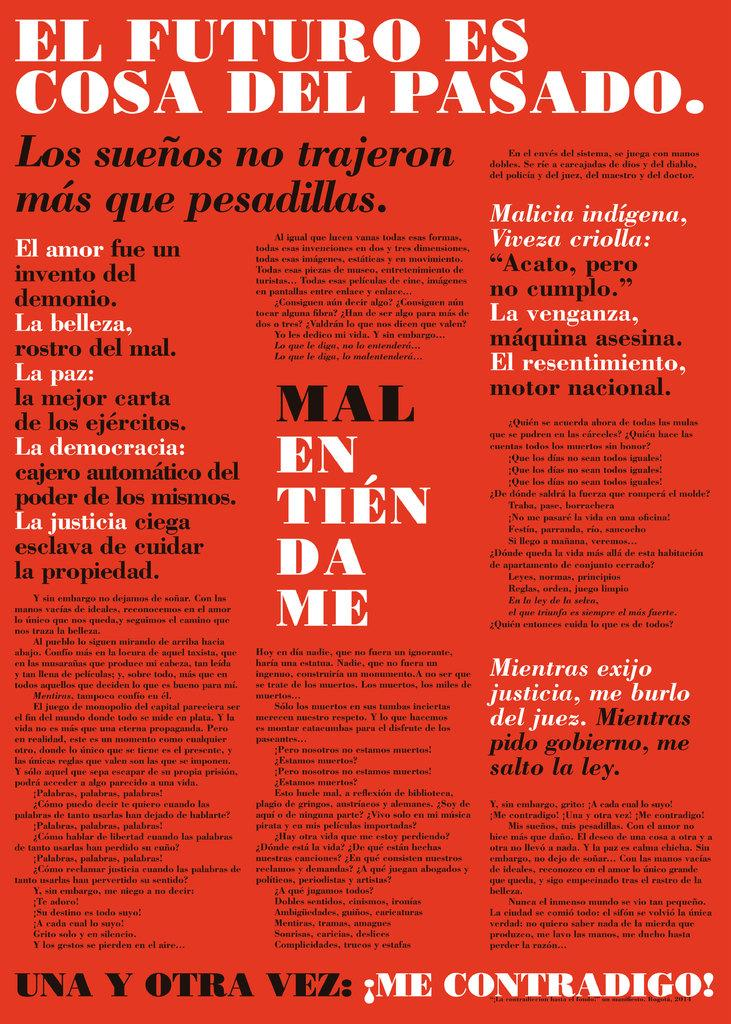What color is the poster in the image? The poster is red. What can be found on the poster besides its color? There is text on the poster. Can you see any waves in the image? There are no waves present in the image; it features a red poster with text. What type of memory is stored in the poster? The poster does not have any memory storage capabilities; it is a visual representation with text. 